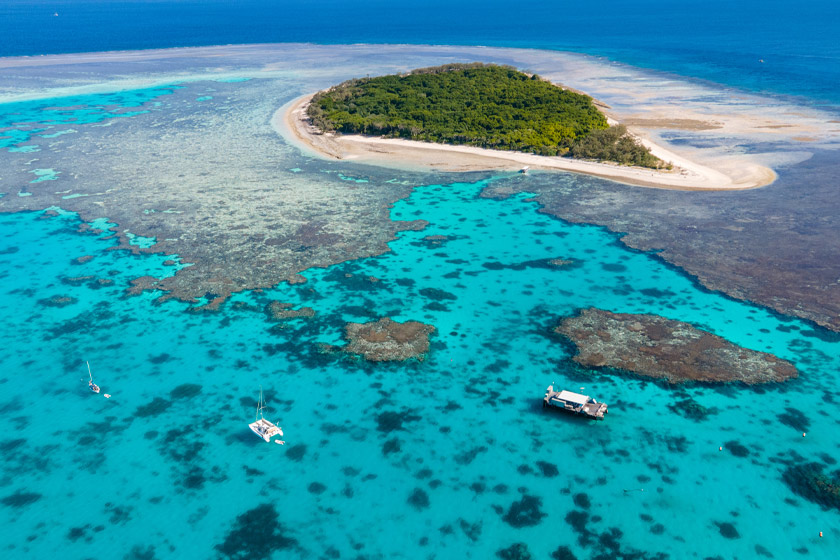Can you explain the ecological significance of coral reefs like the one shown in the image? Coral reefs, such as the Great Barrier Reef shown here, play a crucial ecological role in marine environments. They provide habitat and shelter for many marine organisms, support biodiversity that includes numerous species of fish, mollusks, and crustaceans, and offer protection to coastlines against the effects of waves and storms. Reefs are also vital to the local economies through their contribution to fishing industries and eco-tourism, but they are increasingly threatened by climate change, pollution, and overfishing, necessitating significant conservation efforts. 